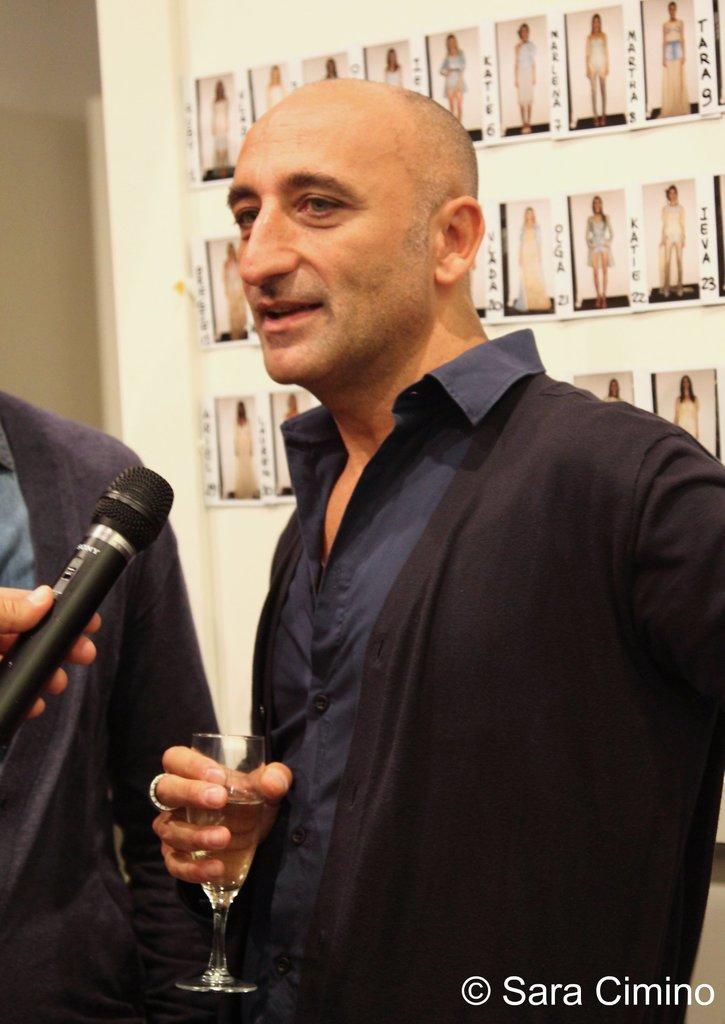How many people are in the image? There are three persons standing in the image. What is the surface on which the persons are standing? The persons are standing on the floor. What can be seen in the background of the image? There is a wall in the background of the image. What is attached to the wall? Photo frames are attached to the wall. Can you tell me how the farmer is jumping in the image? There is no farmer or jumping activity depicted in the image; it features three persons standing on the floor. 